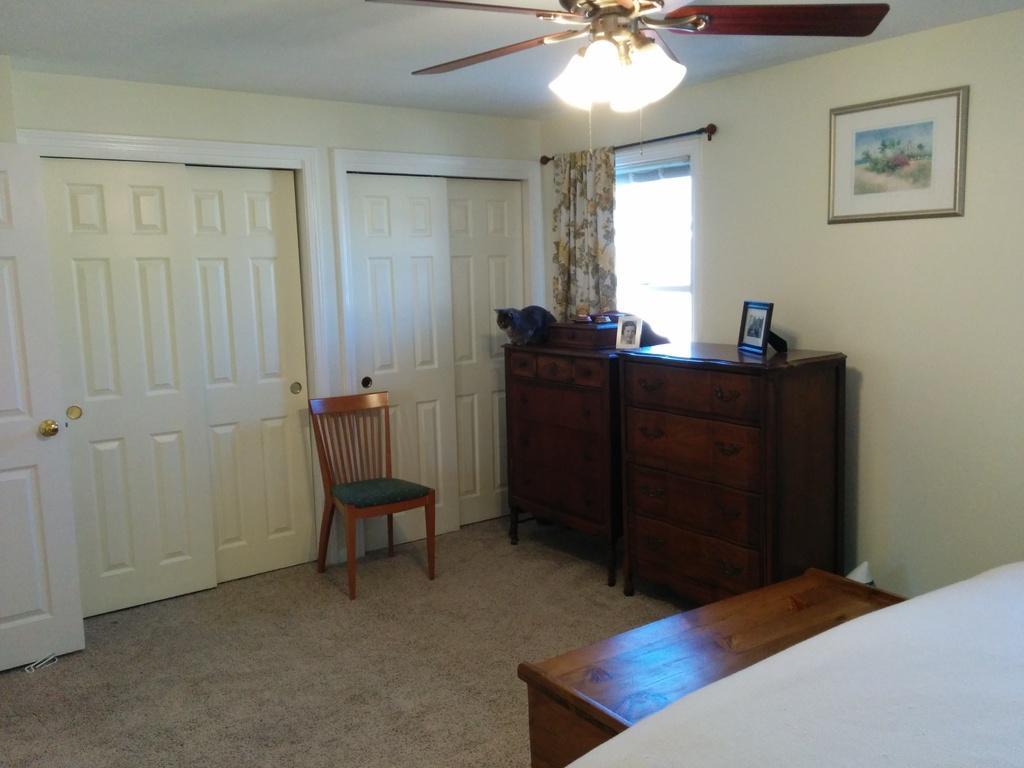How would you summarize this image in a sentence or two? In this image there is a chair,wardrobe at the top of the image there is a fan and at the right side of the image there is a painting and at the left side of the image there is a door. 